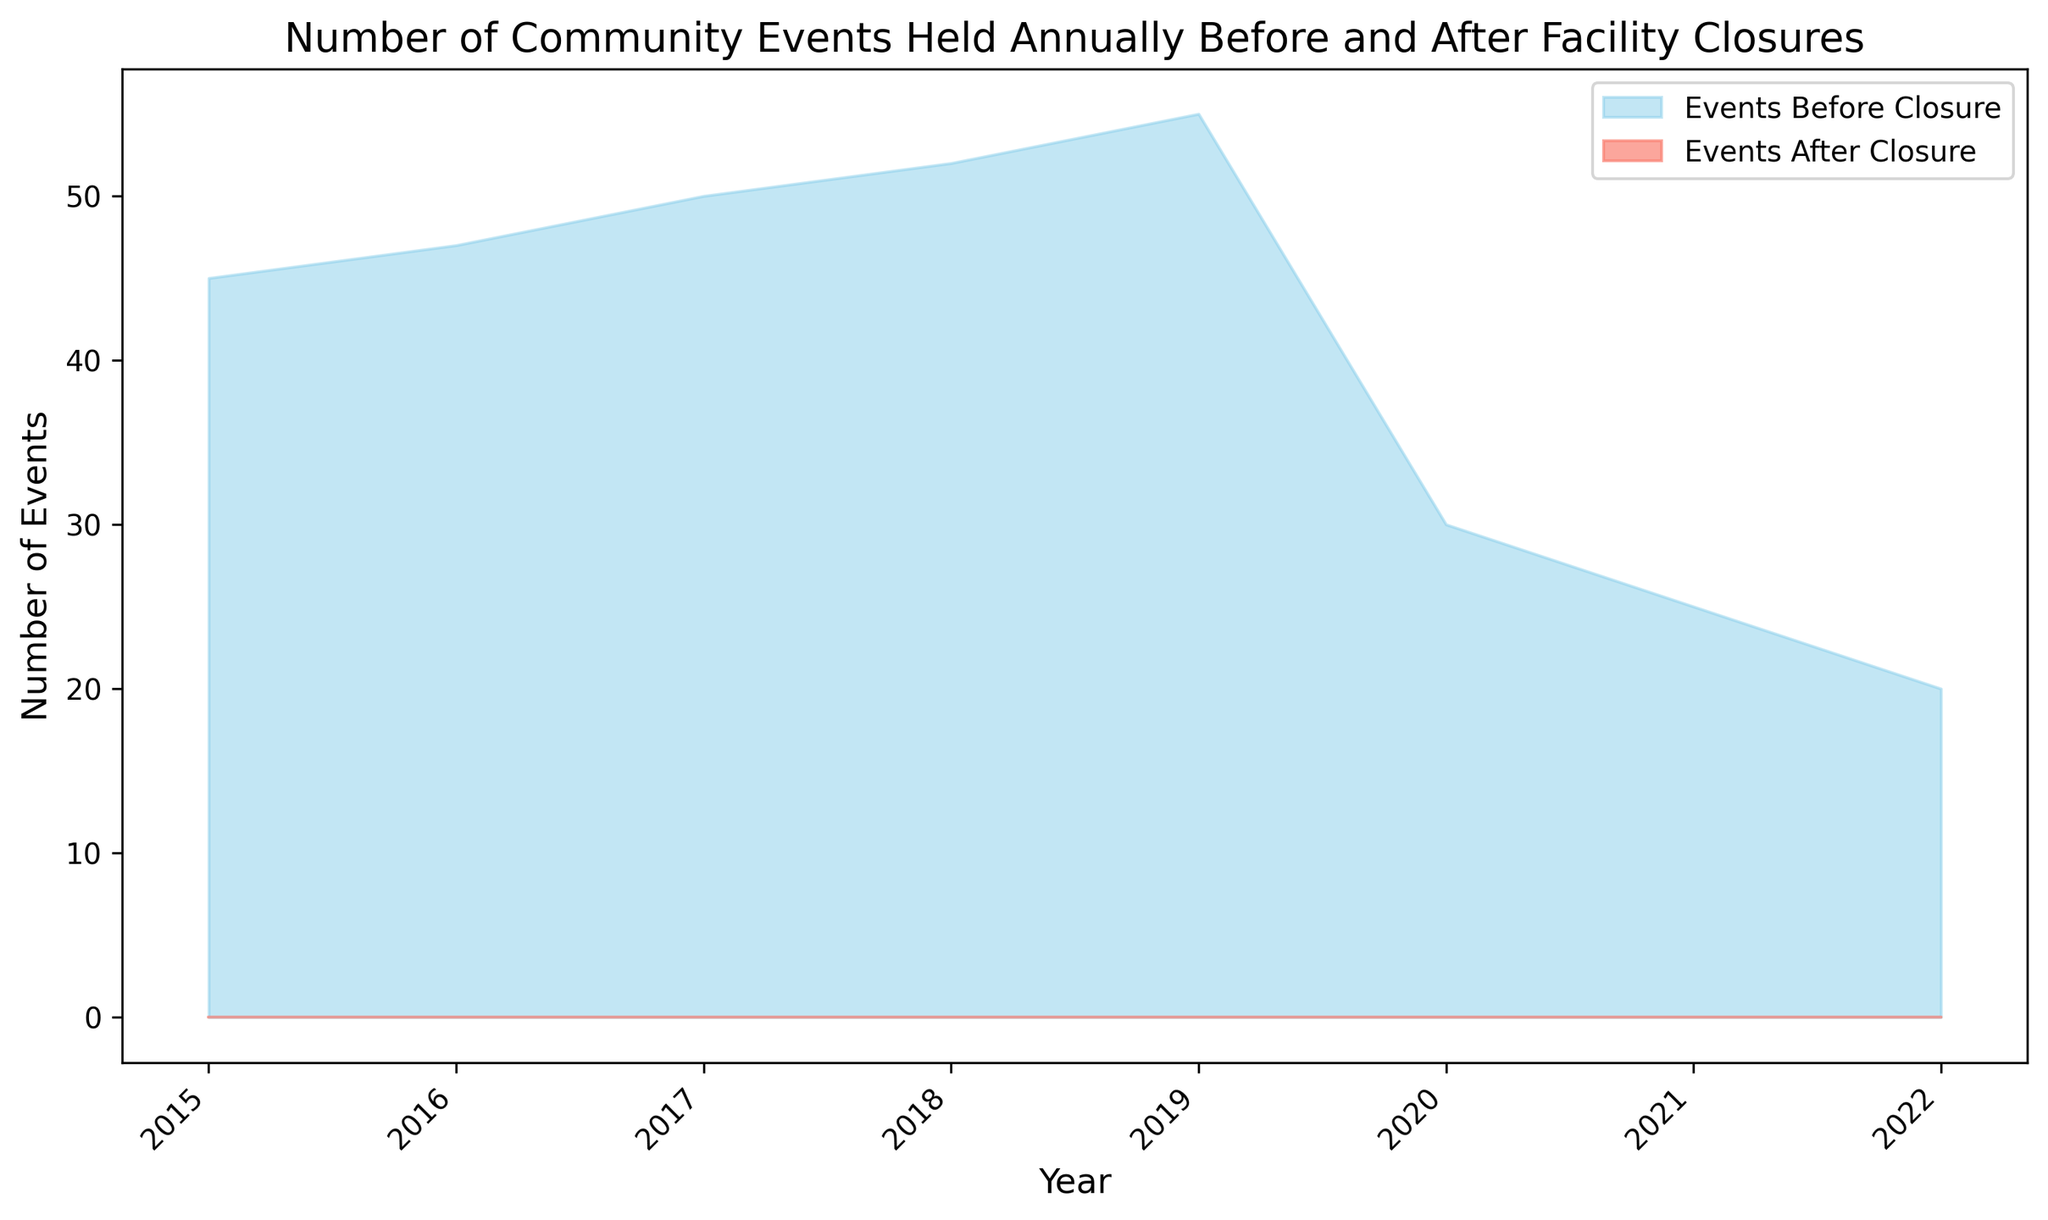What is the number of events held in 2019 before the facility closures? According to the chart, the number of events held in 2019 before the closures is represented by the sky blue area. The figure indicates that the number was 55.
Answer: 55 What is the trend in the number of community events held annually before the facility closures from 2015 to 2019? The sky blue area shows a steadily increasing trend from 45 events in 2015 to 55 events in 2019 before the facility closures.
Answer: Steadily increasing How did the number of events change from 2019 to 2020 after the facility closures? The chart shows that the number of events dropped sharply from 55 (before closures) to 30 (after closures) between 2019 and 2020.
Answer: Dropped sharply What is the difference in the number of events between 2020 and 2022 after the facility closures? We look at the salmon-colored area for the number of events after the closures, which decreased from 30 in 2020 to 20 in 2022. The difference is 30 - 20 = 10.
Answer: 10 Comparing 2020 and 2021, in which year were more events held after the facility closures? The salmon-colored area indicates more events were held in 2020 (30 events) compared to 2021 (25 events).
Answer: 2020 How many total events were held in 2018 cumulatively before and after the closures? Only the sky blue area indicates that 52 events were held in 2018 before the closures. The salmon area indicating events after closures begins from 2020. Therefore, the total for 2018 is 52.
Answer: 52 What is the overall decrease in the number of events from 2019 before the closures to 2022 after the closures? The number of events was 55 in 2019 (before closures) and decreased to 20 in 2022 (after closures). The decrease is 55 - 20 = 35.
Answer: 35 Was there any year when the number of events held after the facility closures was higher than before? By comparing the sky blue area (before) and the salmon area (after) for each year, there is no year in which the number of events held after the closures exceeded those before.
Answer: No 